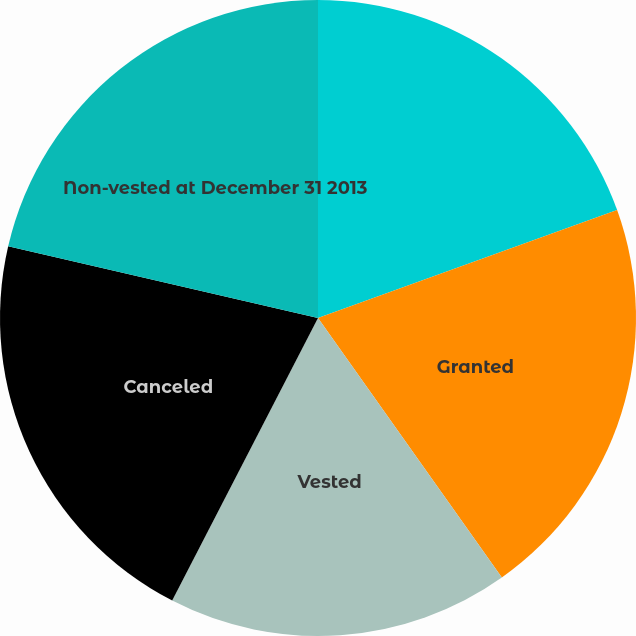Convert chart. <chart><loc_0><loc_0><loc_500><loc_500><pie_chart><fcel>Non-vested at January 1 2013<fcel>Granted<fcel>Vested<fcel>Canceled<fcel>Non-vested at December 31 2013<nl><fcel>19.49%<fcel>20.7%<fcel>17.39%<fcel>21.04%<fcel>21.38%<nl></chart> 